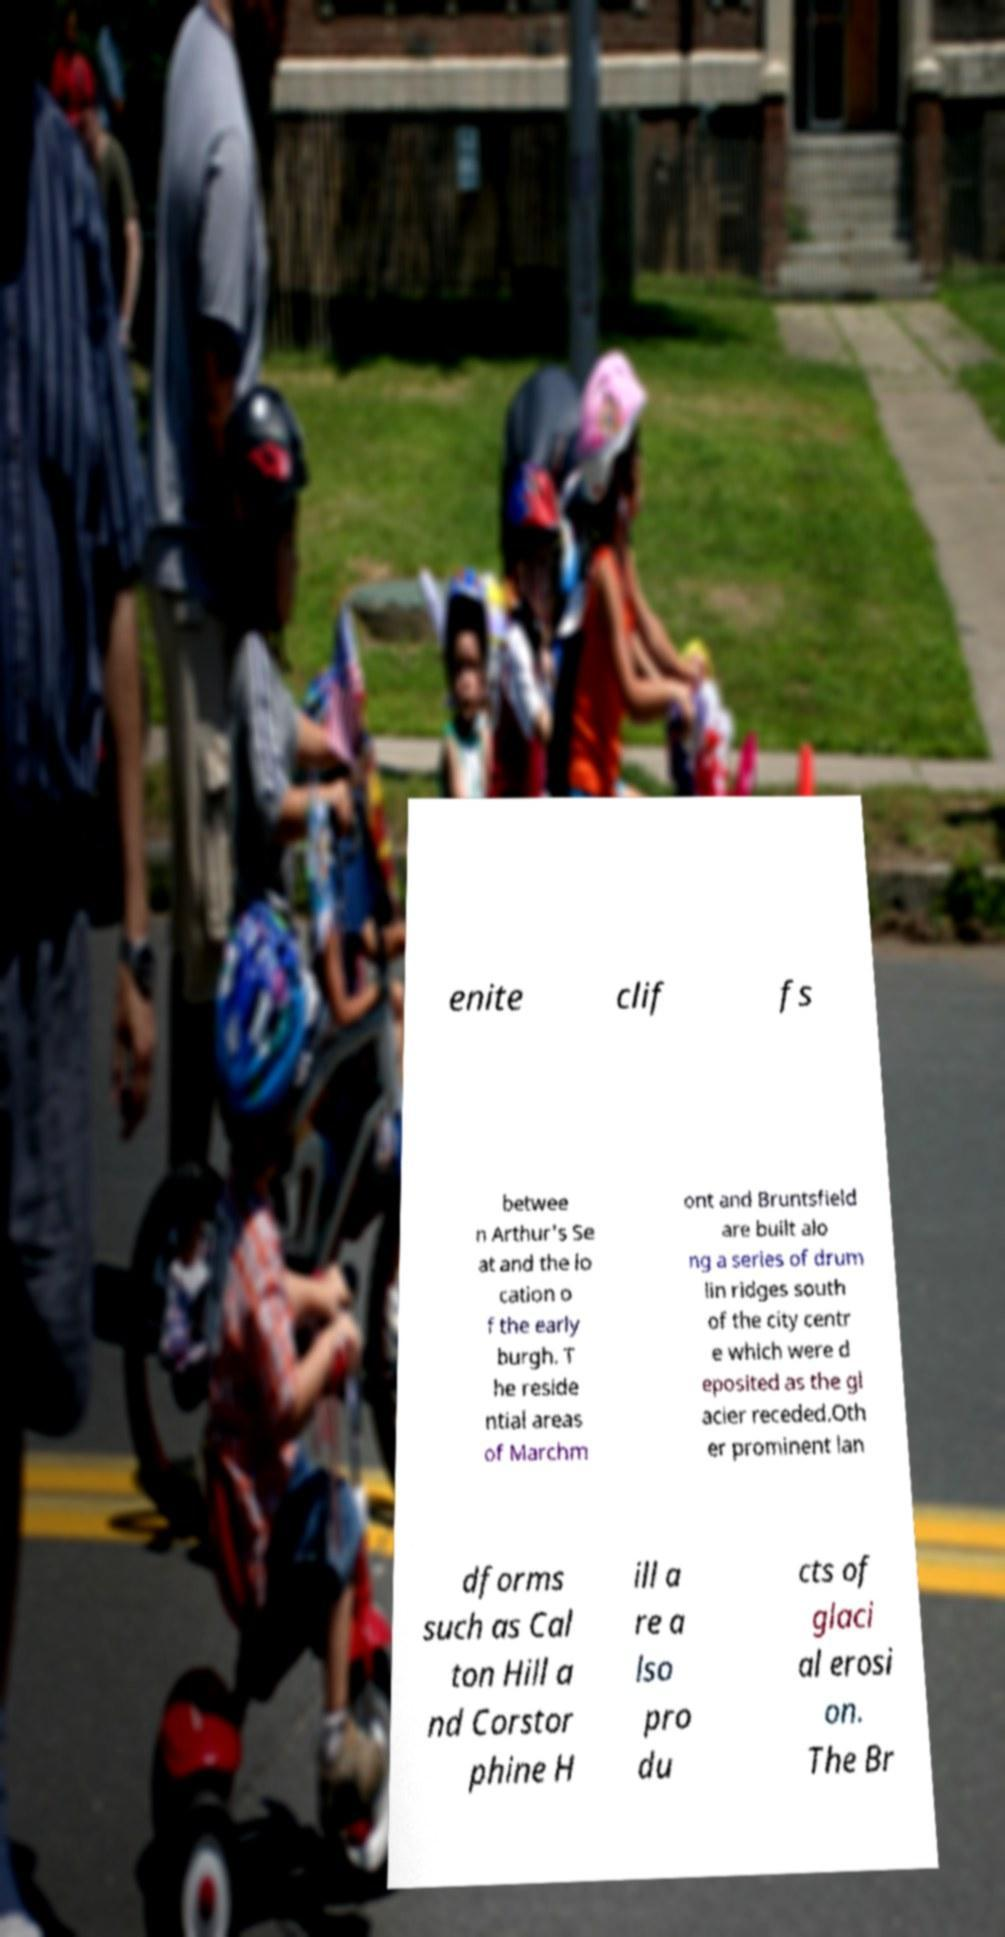Could you extract and type out the text from this image? enite clif fs betwee n Arthur's Se at and the lo cation o f the early burgh. T he reside ntial areas of Marchm ont and Bruntsfield are built alo ng a series of drum lin ridges south of the city centr e which were d eposited as the gl acier receded.Oth er prominent lan dforms such as Cal ton Hill a nd Corstor phine H ill a re a lso pro du cts of glaci al erosi on. The Br 